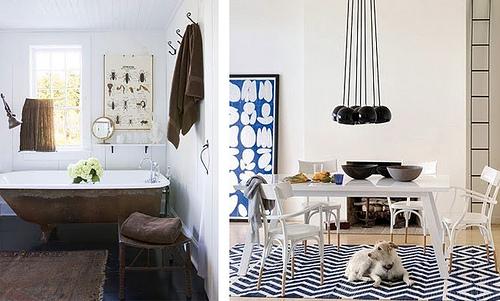How many rooms are shown?
Write a very short answer. 2. Where is the dog?
Write a very short answer. Under table. Where are the towels?
Quick response, please. On racks. 